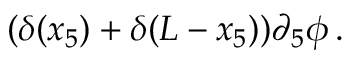Convert formula to latex. <formula><loc_0><loc_0><loc_500><loc_500>( \delta ( x _ { 5 } ) + \delta ( L - x _ { 5 } ) ) \partial _ { 5 } \phi \, .</formula> 